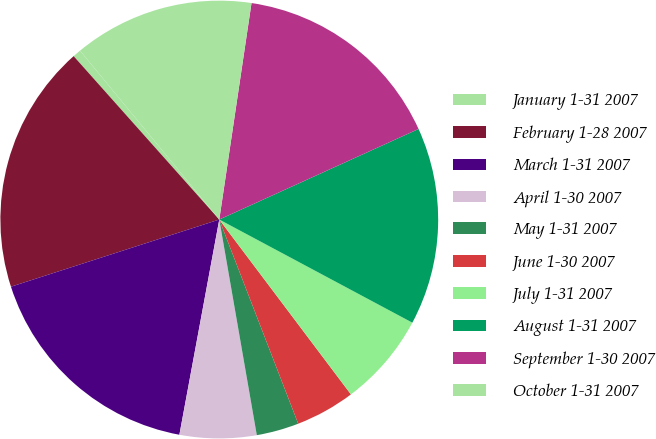<chart> <loc_0><loc_0><loc_500><loc_500><pie_chart><fcel>January 1-31 2007<fcel>February 1-28 2007<fcel>March 1-31 2007<fcel>April 1-30 2007<fcel>May 1-31 2007<fcel>June 1-30 2007<fcel>July 1-31 2007<fcel>August 1-31 2007<fcel>September 1-30 2007<fcel>October 1-31 2007<nl><fcel>0.61%<fcel>18.38%<fcel>17.12%<fcel>5.66%<fcel>3.13%<fcel>4.4%<fcel>6.92%<fcel>14.6%<fcel>15.86%<fcel>13.33%<nl></chart> 